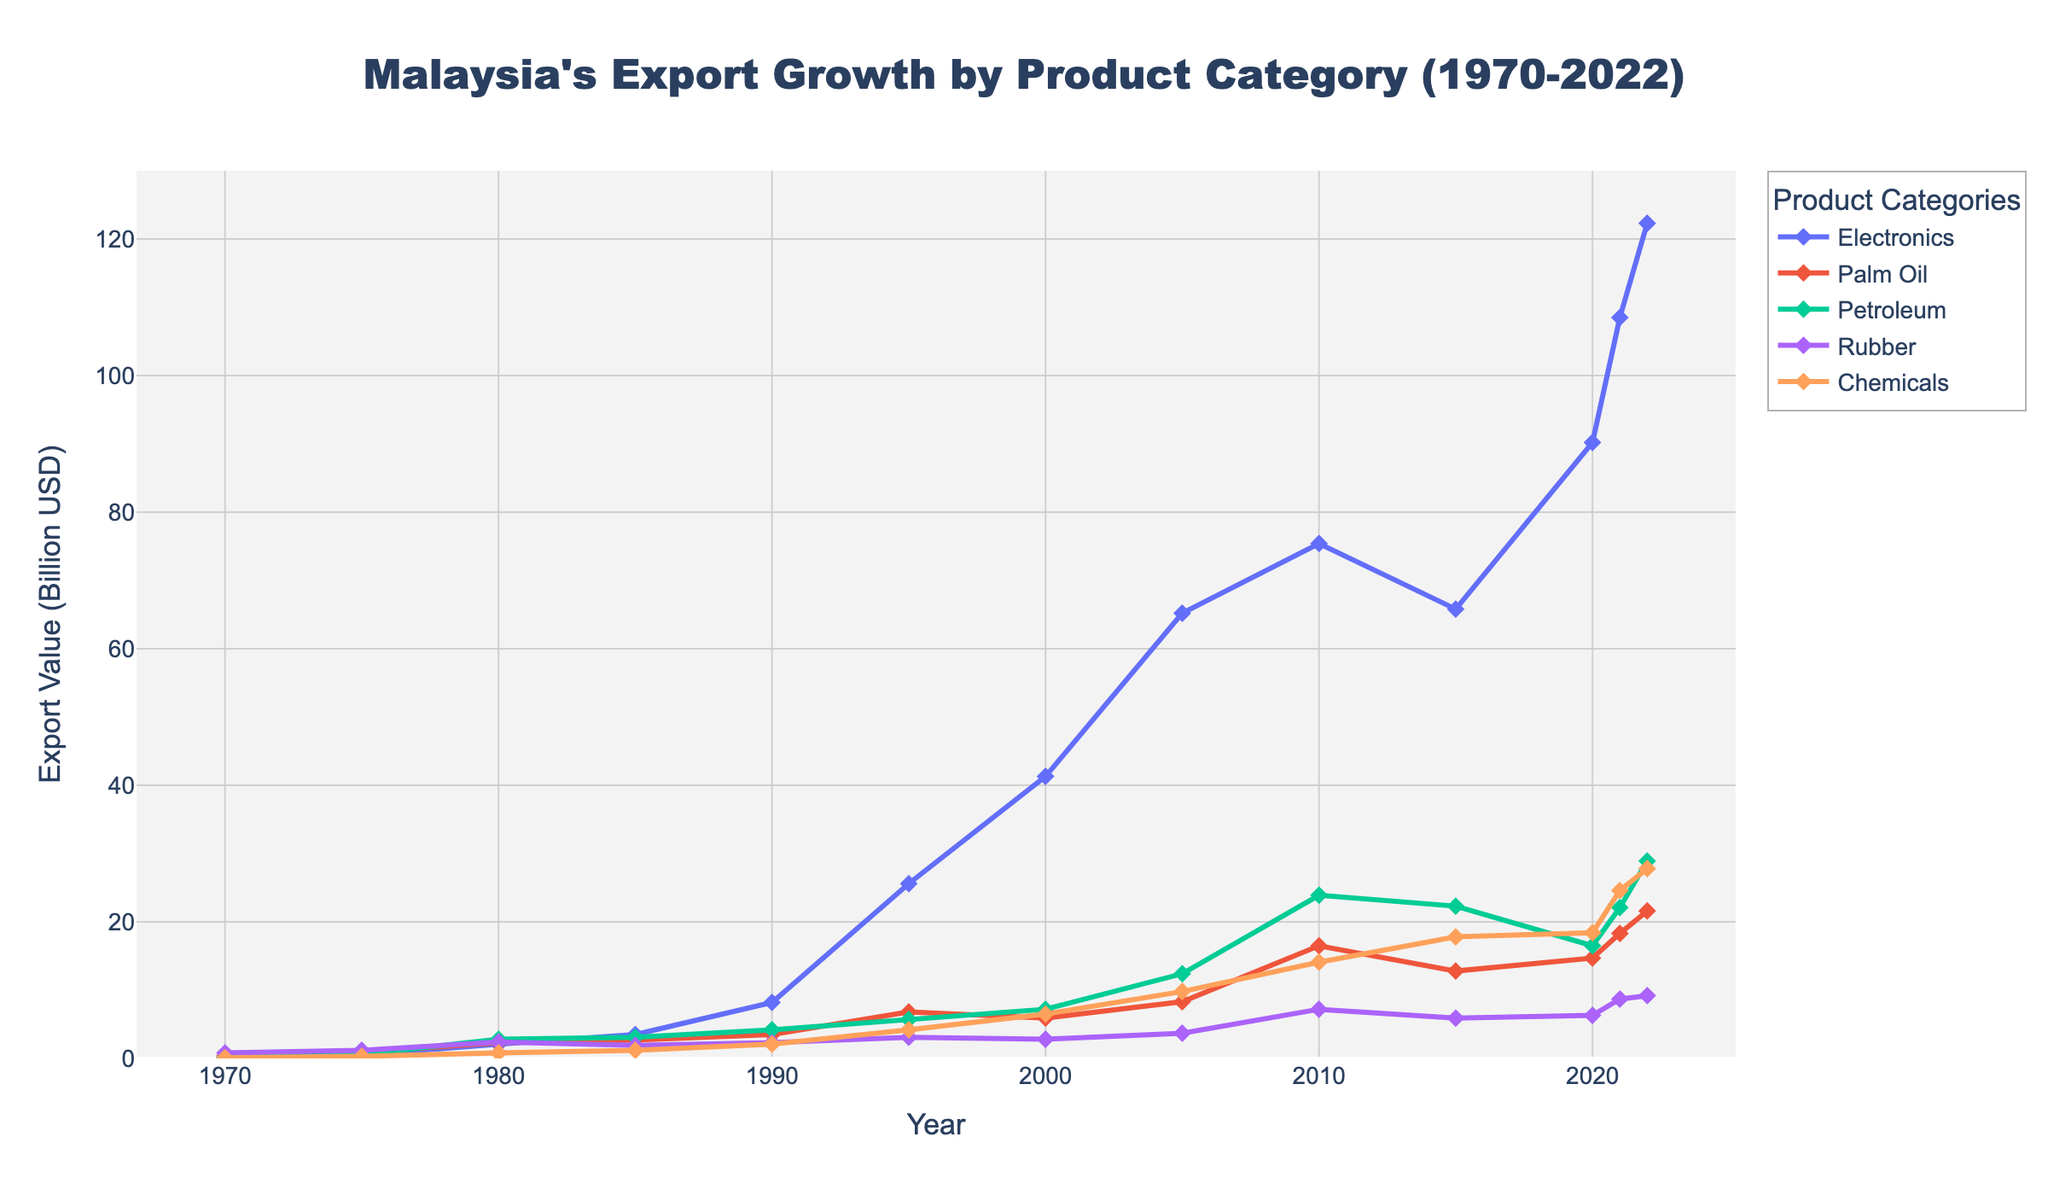What is the export value of Electronics in 2022? Locate the category 'Electronics' on the chart and check the export value for the year 2022; it is at the top of its line.
Answer: 122.3 Billion USD How much did the export value of Palm Oil increase from 1970 to 2022? Find the Palm Oil values for 1970 and 2022 on the chart and subtract the earlier value from the later one: 21.6 - 0.4 = 21.2.
Answer: 21.2 Billion USD Which product category had the highest export value in 2021? Compare the values of all product categories for 2021 and identify the highest one: Electronics.
Answer: Electronics What is the average export value of Rubber from 1970 to 2022? Sum all the Rubber values and divide by the number of years: (0.8 + 1.2 + 2.4 + 1.9 + 2.3 + 3.1 + 2.8 + 3.7 + 7.2 + 5.9 + 6.3 + 8.7 + 9.2)/13 ≈ 4.24.
Answer: 4.24 Billion USD Which year saw the greatest increase in total exports compared to the previous year, and by how much? Calculate the differences for successive years and identify the year with the largest difference: 2021 (299.2) - 2020 (231.7) = 67.5.
Answer: 2021, 67.5 Billion USD By how much did the export value for Petroleum change between 2000 and 2015? Find the Petroleum values for 2000 and 2015 and subtract: 22.3 - 7.2 = 15.1.
Answer: 15.1 Billion USD Compare the export values of Chemicals and Palm Oil in 2022; which one is higher and by how much? Find the values for both categories in 2022 and subtract Palm Oil from Chemicals: 27.8 - 21.6 = 6.2.
Answer: Chemicals by 6.2 Billion USD During which decade did the export value of Electronics experience the most significant growth? Assess the increments per decade by checking the values and identifying the largest increase: From the mid-90s to 2005 (1990 to 2000), an increase from 41.3 to 65.2 = 23.9.
Answer: 1990s What trend do you observe for Rubber exports from 1970 to 2022? Look at the Rubber line on the chart; note the initial increase, gradual stability, and steady rise over the years.
Answer: Gradual increase with stabilization and recent steady growth 